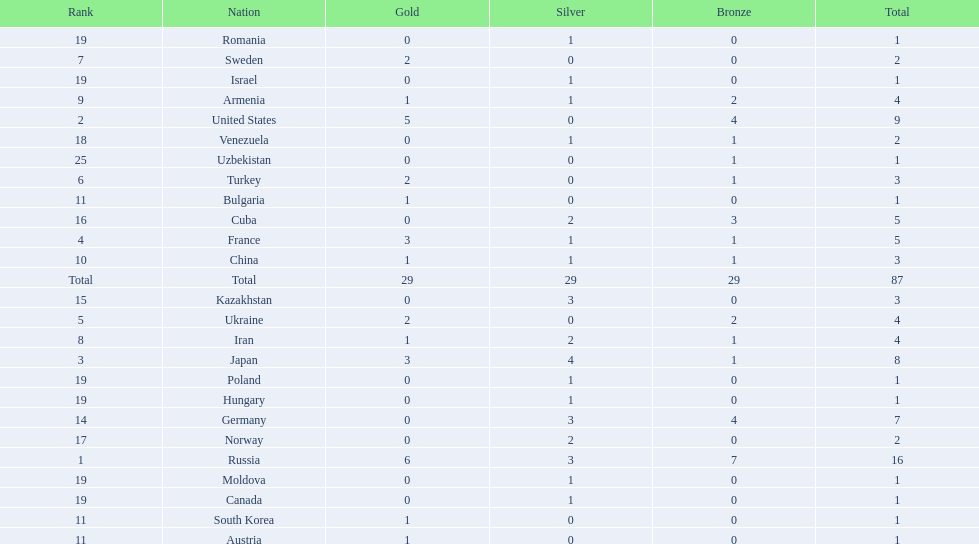What nations have one gold medal? Iran, Armenia, China, Austria, Bulgaria, South Korea. Of these, which nations have zero silver medals? Austria, Bulgaria, South Korea. Of these, which nations also have zero bronze medals? Austria. 